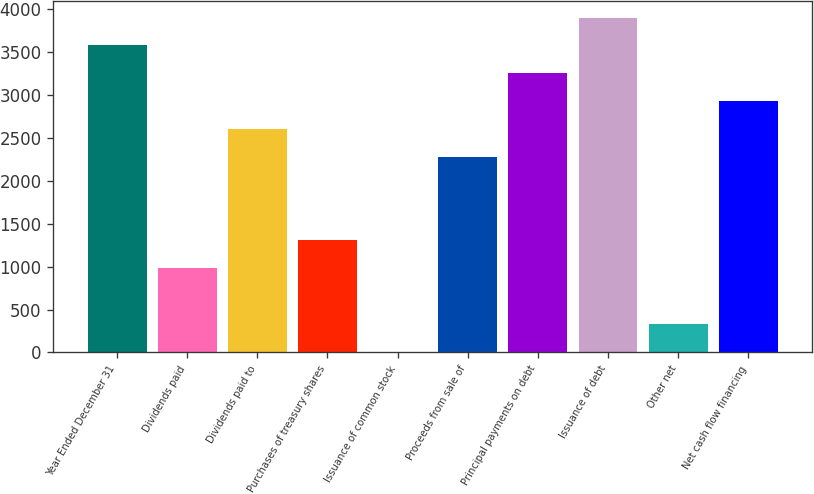<chart> <loc_0><loc_0><loc_500><loc_500><bar_chart><fcel>Year Ended December 31<fcel>Dividends paid<fcel>Dividends paid to<fcel>Purchases of treasury shares<fcel>Issuance of common stock<fcel>Proceeds from sale of<fcel>Principal payments on debt<fcel>Issuance of debt<fcel>Other net<fcel>Net cash flow financing<nl><fcel>3580<fcel>980<fcel>2605<fcel>1305<fcel>5<fcel>2280<fcel>3255<fcel>3905<fcel>330<fcel>2930<nl></chart> 